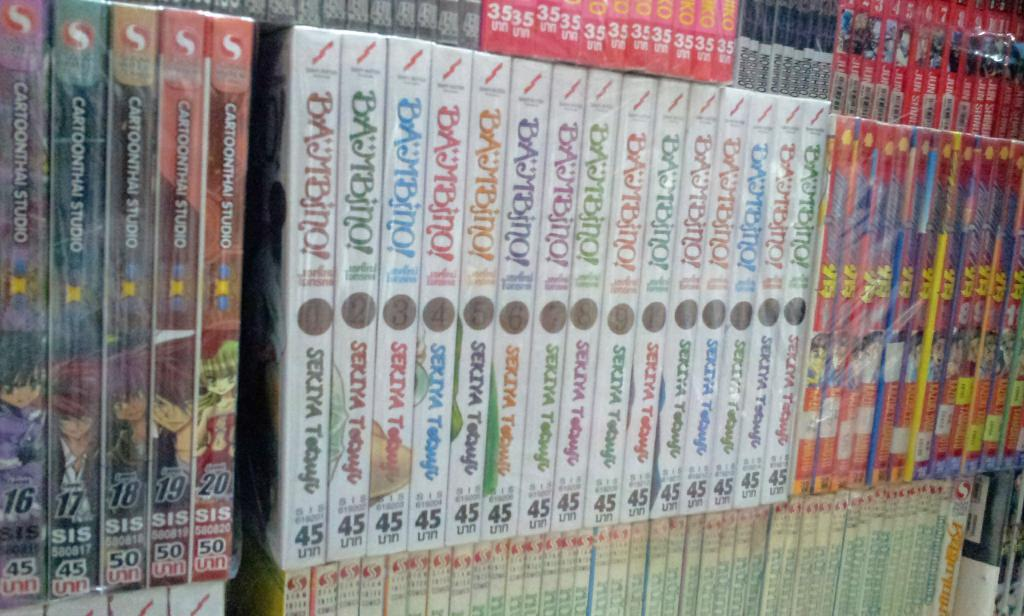<image>
Provide a brief description of the given image. A group of series' with the series on the left being by Cartoonthai Studio. 